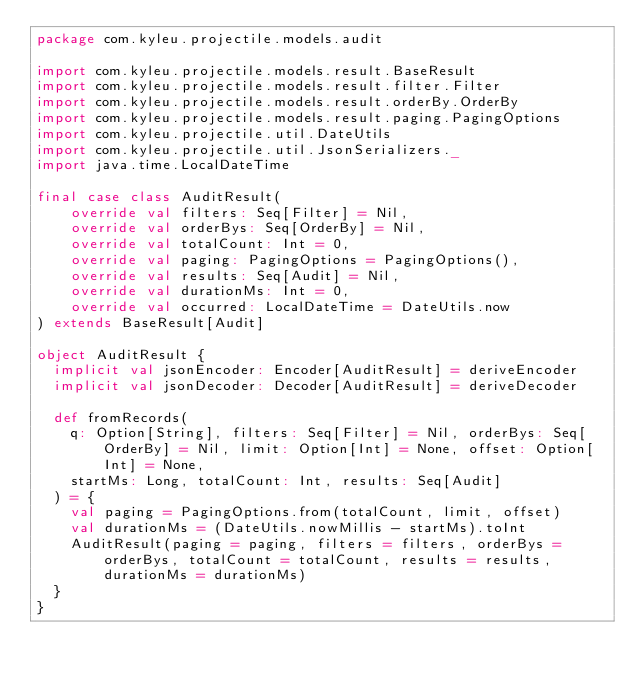Convert code to text. <code><loc_0><loc_0><loc_500><loc_500><_Scala_>package com.kyleu.projectile.models.audit

import com.kyleu.projectile.models.result.BaseResult
import com.kyleu.projectile.models.result.filter.Filter
import com.kyleu.projectile.models.result.orderBy.OrderBy
import com.kyleu.projectile.models.result.paging.PagingOptions
import com.kyleu.projectile.util.DateUtils
import com.kyleu.projectile.util.JsonSerializers._
import java.time.LocalDateTime

final case class AuditResult(
    override val filters: Seq[Filter] = Nil,
    override val orderBys: Seq[OrderBy] = Nil,
    override val totalCount: Int = 0,
    override val paging: PagingOptions = PagingOptions(),
    override val results: Seq[Audit] = Nil,
    override val durationMs: Int = 0,
    override val occurred: LocalDateTime = DateUtils.now
) extends BaseResult[Audit]

object AuditResult {
  implicit val jsonEncoder: Encoder[AuditResult] = deriveEncoder
  implicit val jsonDecoder: Decoder[AuditResult] = deriveDecoder

  def fromRecords(
    q: Option[String], filters: Seq[Filter] = Nil, orderBys: Seq[OrderBy] = Nil, limit: Option[Int] = None, offset: Option[Int] = None,
    startMs: Long, totalCount: Int, results: Seq[Audit]
  ) = {
    val paging = PagingOptions.from(totalCount, limit, offset)
    val durationMs = (DateUtils.nowMillis - startMs).toInt
    AuditResult(paging = paging, filters = filters, orderBys = orderBys, totalCount = totalCount, results = results, durationMs = durationMs)
  }
}
</code> 